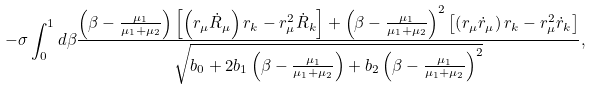Convert formula to latex. <formula><loc_0><loc_0><loc_500><loc_500>- \sigma \int _ { 0 } ^ { 1 } d \beta \frac { \left ( \beta - \frac { \mu _ { 1 } } { \mu _ { 1 } + \mu _ { 2 } } \right ) \left [ \left ( r _ { \mu } \dot { R } _ { \mu } \right ) r _ { k } - r _ { \mu } ^ { 2 } \dot { R } _ { k } \right ] + \left ( \beta - \frac { \mu _ { 1 } } { \mu _ { 1 } + \mu _ { 2 } } \right ) ^ { 2 } \left [ \left ( r _ { \mu } \dot { r } _ { \mu } \right ) r _ { k } - r _ { \mu } ^ { 2 } \dot { r } _ { k } \right ] } { \sqrt { b _ { 0 } + 2 b _ { 1 } \left ( \beta - \frac { \mu _ { 1 } } { \mu _ { 1 } + \mu _ { 2 } } \right ) + b _ { 2 } \left ( \beta - \frac { \mu _ { 1 } } { \mu _ { 1 } + \mu _ { 2 } } \right ) ^ { 2 } } } ,</formula> 